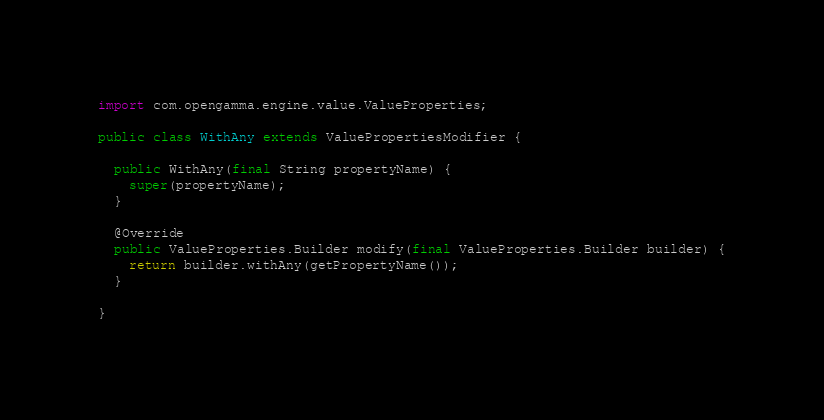<code> <loc_0><loc_0><loc_500><loc_500><_Java_>import com.opengamma.engine.value.ValueProperties;

public class WithAny extends ValuePropertiesModifier {

  public WithAny(final String propertyName) {
    super(propertyName);
  }

  @Override
  public ValueProperties.Builder modify(final ValueProperties.Builder builder) {
    return builder.withAny(getPropertyName());
  }

}
</code> 